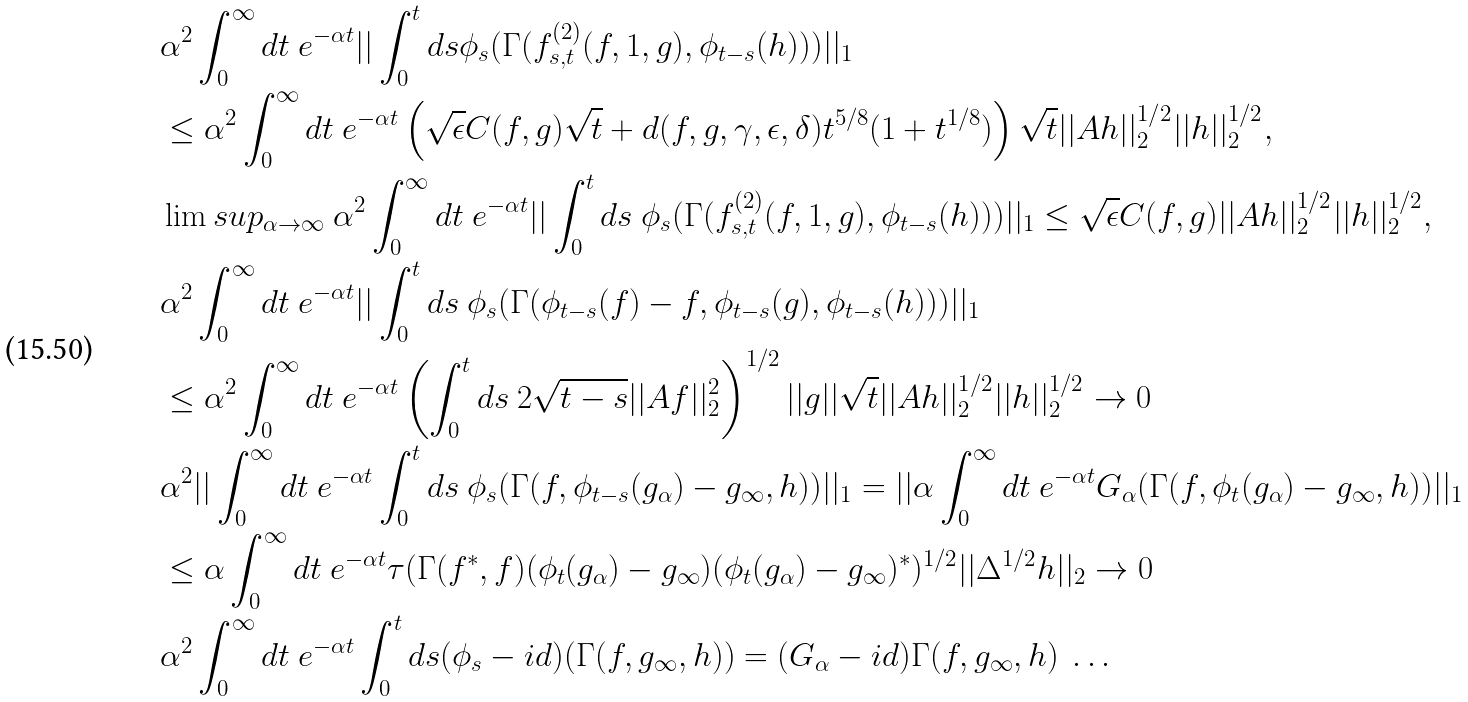Convert formula to latex. <formula><loc_0><loc_0><loc_500><loc_500>& \alpha ^ { 2 } \int _ { 0 } ^ { \infty } d t \ e ^ { - \alpha t } | | \int _ { 0 } ^ { t } d s \phi _ { s } ( \Gamma ( f _ { s , t } ^ { ( 2 ) } ( f , 1 , g ) , \phi _ { t - s } ( h ) ) ) | | _ { 1 } \\ & \leq \alpha ^ { 2 } \int _ { 0 } ^ { \infty } d t \ e ^ { - \alpha t } \left ( \sqrt { \epsilon } C ( f , g ) \sqrt { t } + d ( f , g , \gamma , \epsilon , \delta ) t ^ { 5 / 8 } ( 1 + t ^ { 1 / 8 } ) \right ) \sqrt { t } | | A h | | _ { 2 } ^ { 1 / 2 } | | h | | _ { 2 } ^ { 1 / 2 } , \\ & \lim s u p _ { \alpha \rightarrow \infty } \ \alpha ^ { 2 } \int _ { 0 } ^ { \infty } d t \ e ^ { - \alpha t } | | \int _ { 0 } ^ { t } d s \ \phi _ { s } ( \Gamma ( f _ { s , t } ^ { ( 2 ) } ( f , 1 , g ) , \phi _ { t - s } ( h ) ) ) | | _ { 1 } \leq \sqrt { \epsilon } C ( f , g ) | | A h | | _ { 2 } ^ { 1 / 2 } | | h | | _ { 2 } ^ { 1 / 2 } , \\ & \alpha ^ { 2 } \int _ { 0 } ^ { \infty } d t \ e ^ { - \alpha t } | | \int _ { 0 } ^ { t } d s \ \phi _ { s } ( \Gamma ( \phi _ { t - s } ( f ) - f , \phi _ { t - s } ( g ) , \phi _ { t - s } ( h ) ) ) | | _ { 1 } \\ & \leq \alpha ^ { 2 } \int _ { 0 } ^ { \infty } d t \ e ^ { - \alpha t } \left ( \int _ { 0 } ^ { t } d s \ 2 \sqrt { t - s } | | A f | | _ { 2 } ^ { 2 } \right ) ^ { 1 / 2 } | | g | | \sqrt { t } | | A h | | _ { 2 } ^ { 1 / 2 } | | h | | _ { 2 } ^ { 1 / 2 } \rightarrow 0 \\ & \alpha ^ { 2 } | | \int _ { 0 } ^ { \infty } d t \ e ^ { - \alpha t } \int _ { 0 } ^ { t } d s \ \phi _ { s } ( \Gamma ( f , \phi _ { t - s } ( g _ { \alpha } ) - g _ { \infty } , h ) ) | | _ { 1 } = | | \alpha \int _ { 0 } ^ { \infty } d t \ e ^ { - \alpha t } G _ { \alpha } ( \Gamma ( f , \phi _ { t } ( g _ { \alpha } ) - g _ { \infty } , h ) ) | | _ { 1 } \\ & \leq \alpha \int _ { 0 } ^ { \infty } d t \ e ^ { - \alpha t } \tau ( \Gamma ( f ^ { * } , f ) ( \phi _ { t } ( g _ { \alpha } ) - g _ { \infty } ) ( \phi _ { t } ( g _ { \alpha } ) - g _ { \infty } ) ^ { * } ) ^ { 1 / 2 } | | \Delta ^ { 1 / 2 } h | | _ { 2 } \rightarrow 0 \\ & \alpha ^ { 2 } \int _ { 0 } ^ { \infty } d t \ e ^ { - \alpha t } \int _ { 0 } ^ { t } d s ( \phi _ { s } - i d ) ( \Gamma ( f , g _ { \infty } , h ) ) = ( G _ { \alpha } - i d ) \Gamma ( f , g _ { \infty } , h ) \ \dots</formula> 